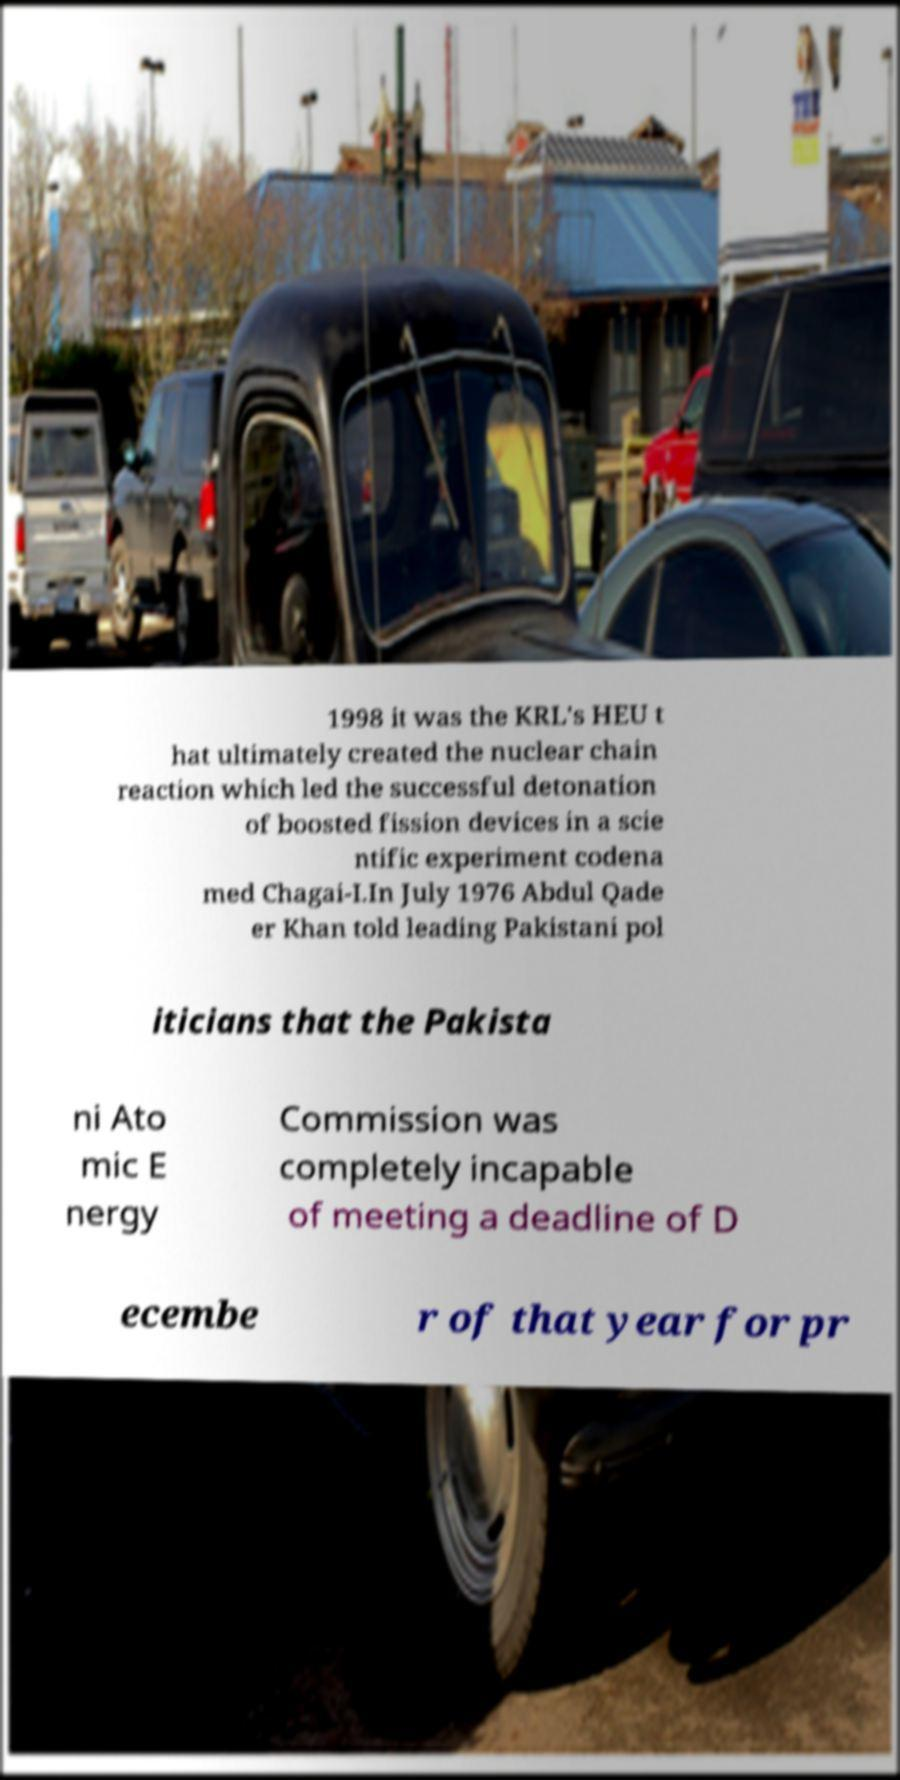What messages or text are displayed in this image? I need them in a readable, typed format. 1998 it was the KRL's HEU t hat ultimately created the nuclear chain reaction which led the successful detonation of boosted fission devices in a scie ntific experiment codena med Chagai-I.In July 1976 Abdul Qade er Khan told leading Pakistani pol iticians that the Pakista ni Ato mic E nergy Commission was completely incapable of meeting a deadline of D ecembe r of that year for pr 